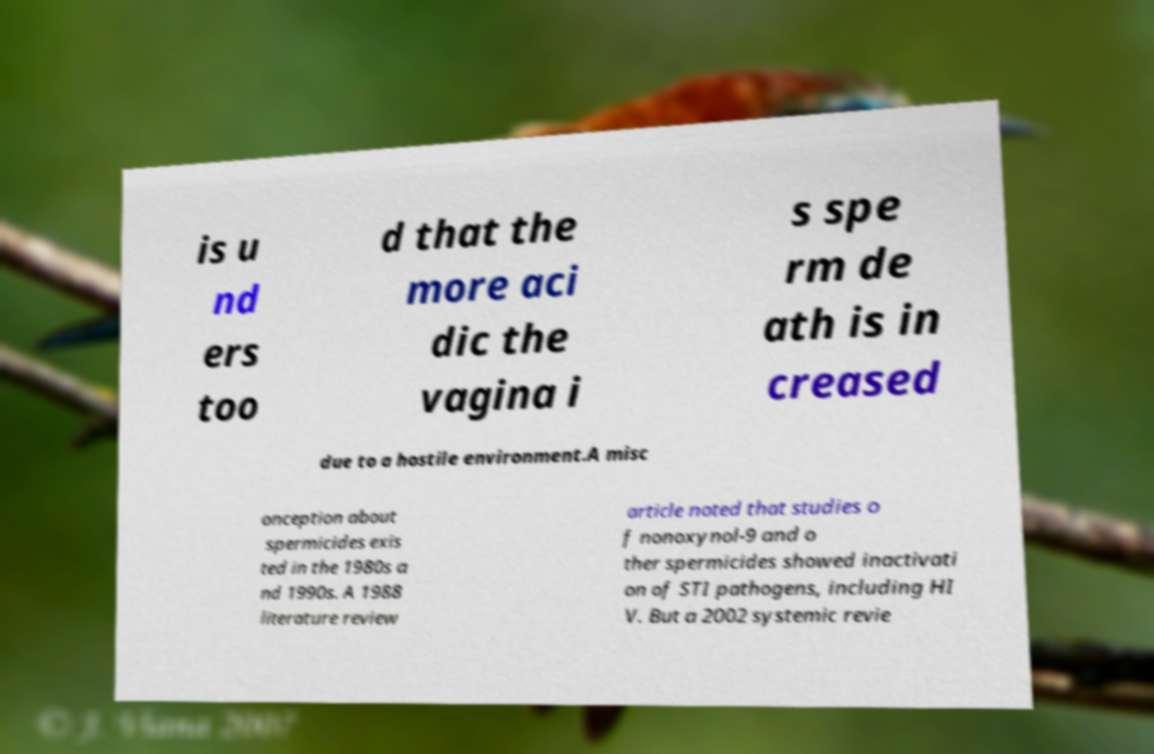For documentation purposes, I need the text within this image transcribed. Could you provide that? is u nd ers too d that the more aci dic the vagina i s spe rm de ath is in creased due to a hostile environment.A misc onception about spermicides exis ted in the 1980s a nd 1990s. A 1988 literature review article noted that studies o f nonoxynol-9 and o ther spermicides showed inactivati on of STI pathogens, including HI V. But a 2002 systemic revie 